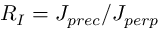Convert formula to latex. <formula><loc_0><loc_0><loc_500><loc_500>R _ { I } = J _ { p r e c } / J _ { p e r p }</formula> 